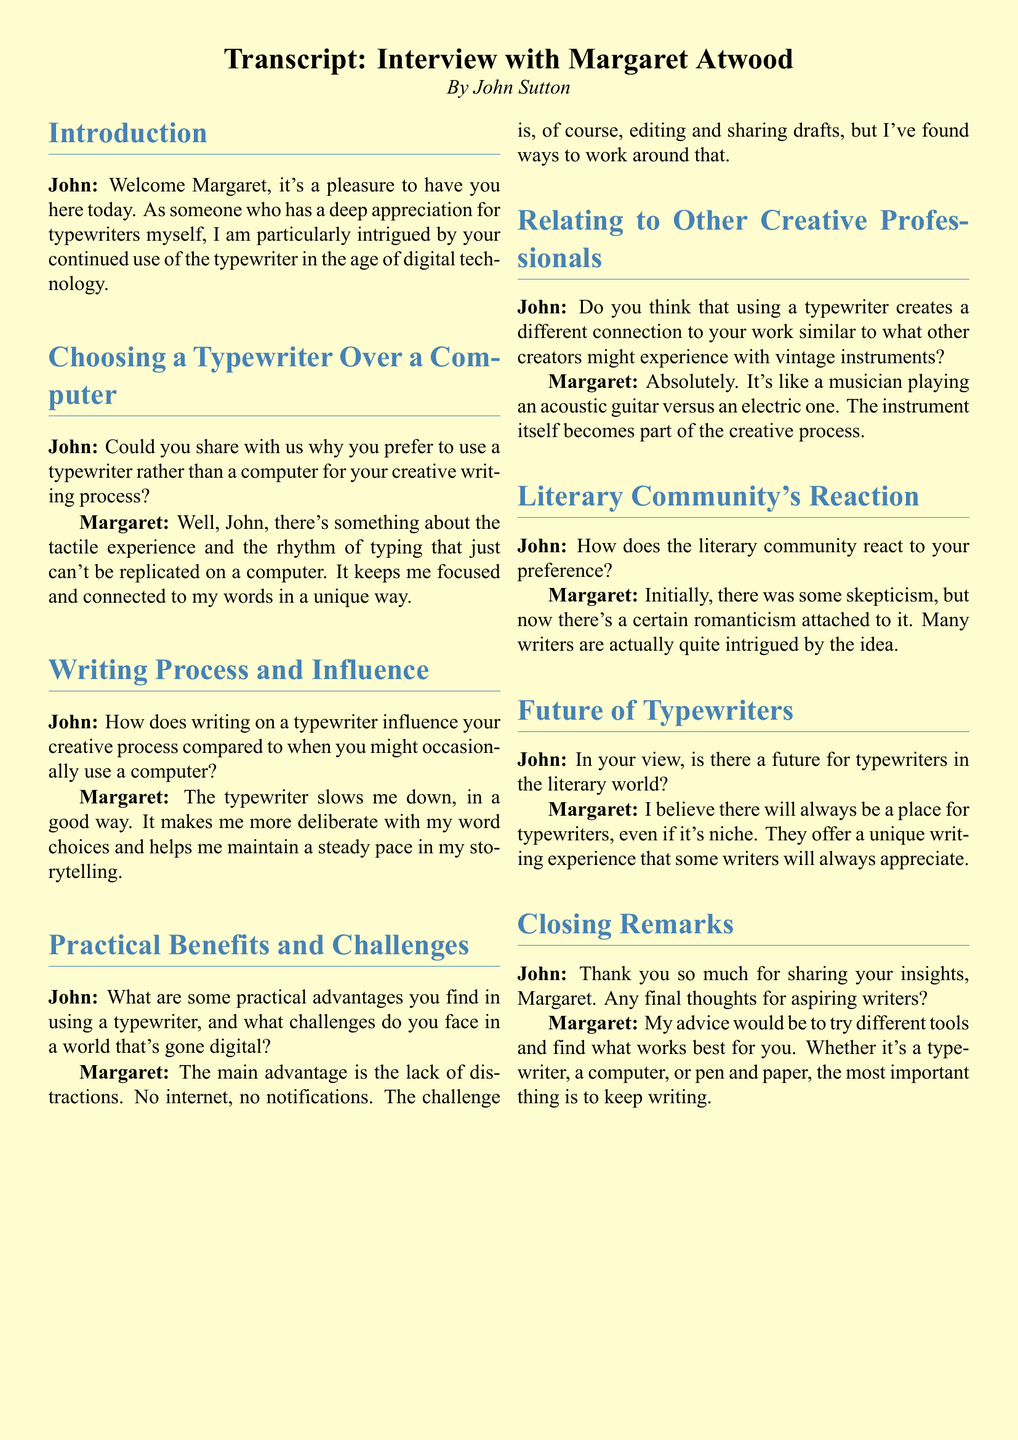What is the name of the novelist interviewed? The document introduces the novelist as Margaret Atwood.
Answer: Margaret Atwood Who is the interviewer? The document specifies that the interview is conducted by John Sutton.
Answer: John Sutton What does Margaret appreciate about using a typewriter? The transcript indicates she appreciates the tactile experience and rhythm of typing.
Answer: Tactile experience and rhythm What advantage does Margaret mention regarding distractions? She states that using a typewriter allows her to avoid distractions like the internet and notifications.
Answer: Lack of distractions How does Margaret describe the typewriter's effect on her writing pace? She mentions that the typewriter slows her down, which she views positively.
Answer: Slows her down positively What specific challenge does Margaret face with typewriters? She highlights editing and sharing drafts as a challenge when using a typewriter.
Answer: Editing and sharing drafts What analogy does Margaret make about typewriters and musical instruments? She compares using a typewriter to a musician playing an acoustic guitar versus an electric one.
Answer: Acoustic guitar vs electric guitar How did the literary community initially react to her preference? She describes the initial reaction as skepticism.
Answer: Skepticism What future does Margaret envision for typewriters? She believes there will always be a niche place for typewriters in the literary world.
Answer: A niche place 